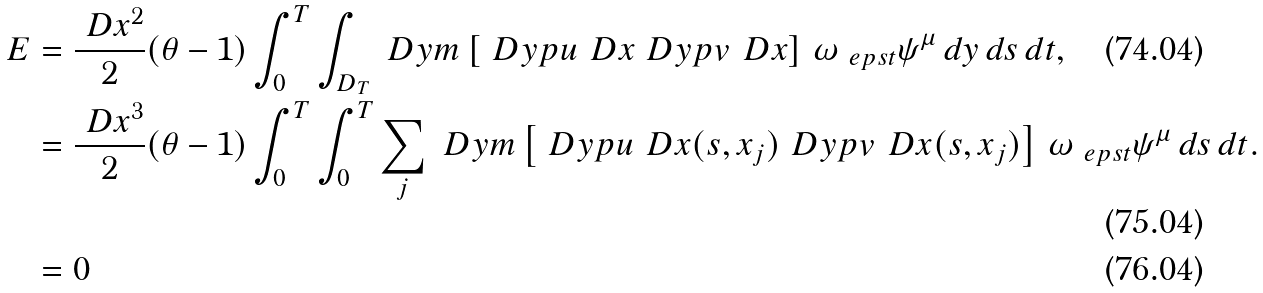Convert formula to latex. <formula><loc_0><loc_0><loc_500><loc_500>E & = \frac { \ D x ^ { 2 } } { 2 } ( \theta - 1 ) \int _ { 0 } ^ { T } \int _ { D _ { T } } \ D y m \left [ \ D y p u _ { \ } D x \ D y p v _ { \ } D x \right ] \, \omega _ { \ e p s t } \psi ^ { \mu } \, d y \, d s \, d t , \\ & = \frac { \ D x ^ { 3 } } { 2 } ( \theta - 1 ) \int _ { 0 } ^ { T } \int _ { 0 } ^ { T } \sum _ { j } \ D y m \left [ \ D y p u _ { \ } D x ( s , x _ { j } ) \ D y p v _ { \ } D x ( s , x _ { j } ) \right ] \, \omega _ { \ e p s t } \psi ^ { \mu } \, d s \, d t . \\ & = 0</formula> 